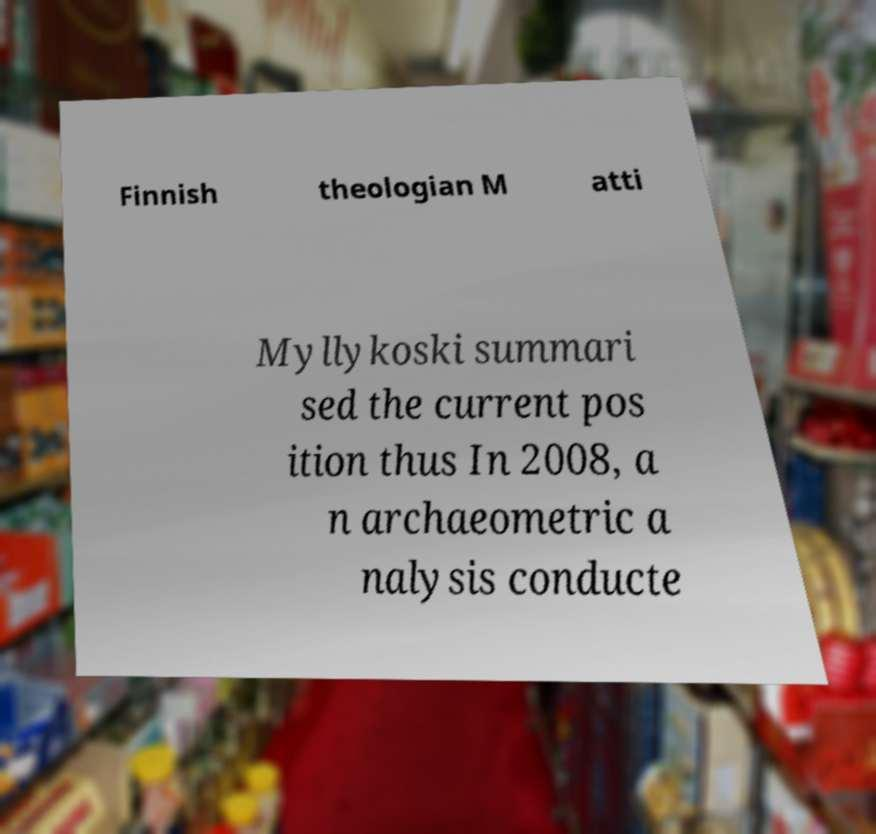There's text embedded in this image that I need extracted. Can you transcribe it verbatim? Finnish theologian M atti Myllykoski summari sed the current pos ition thus In 2008, a n archaeometric a nalysis conducte 